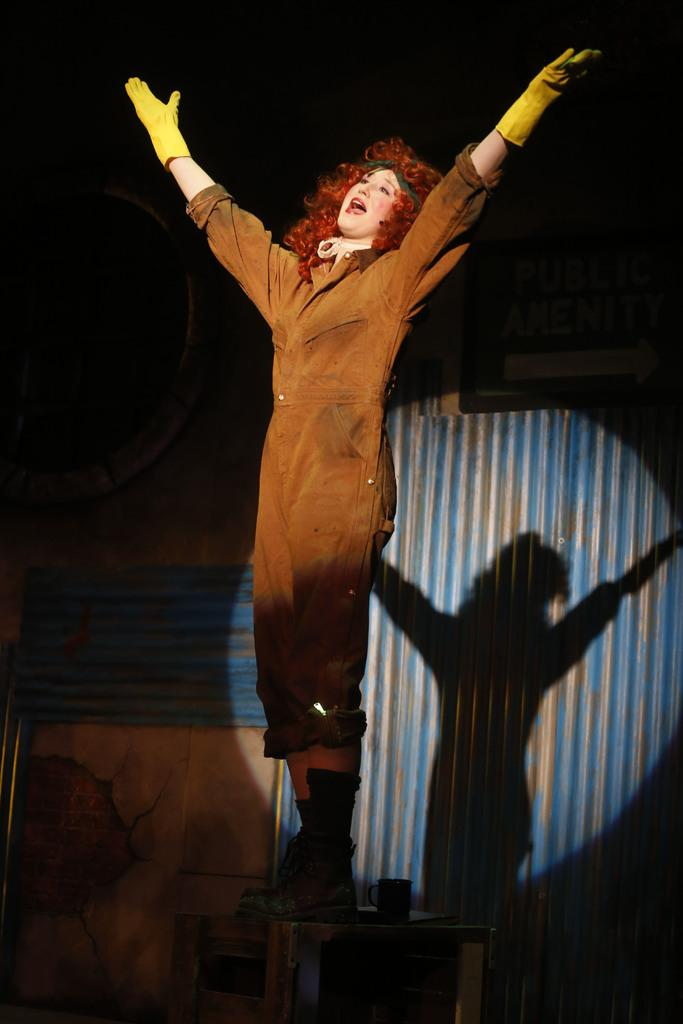What is the person in the image doing? The person is standing on a table in the image. What is the person wearing? The person is wearing a costume. What can be seen in the background of the image? There is a wall in the background of the image. What else is visible on the wall in the background? A shadow is visible on the wall in the background. What type of hat is the pest wearing in the image? There is no pest present in the image, and therefore no hat can be attributed to it. 